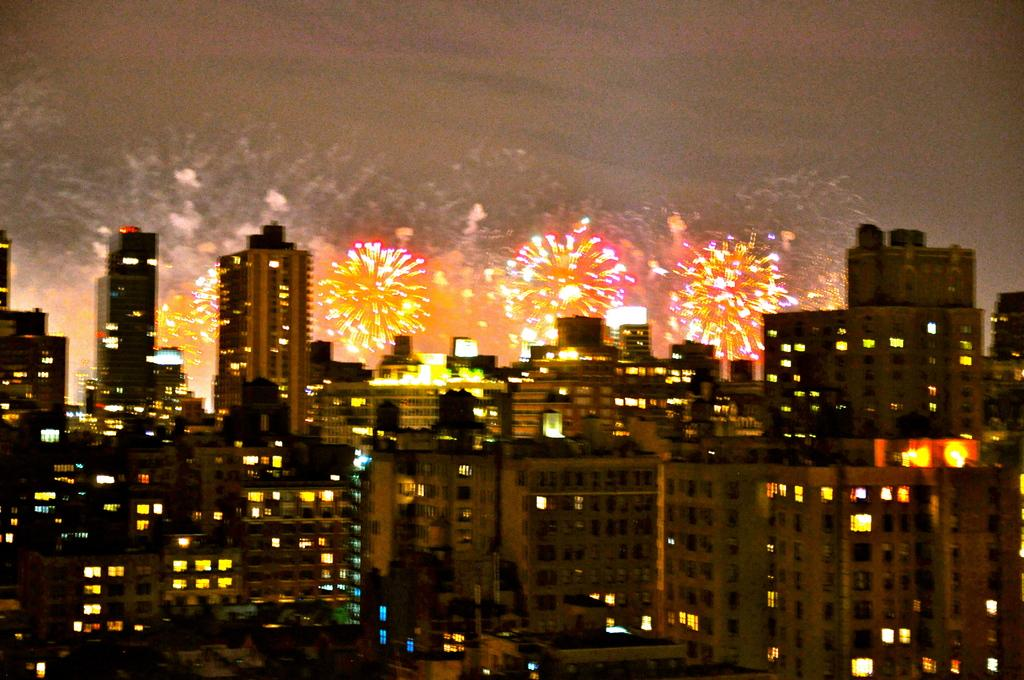What type of structures can be seen in the image? There are buildings in the image. What feature is common to many of the buildings? Windows are visible in the image. What can be seen illuminating the buildings? There are lights in the image. What is happening in the sky in the background of the image? There are sparks in the sky in the background of the image. What type of natural element is visible in the background of the image? Clouds are visible in the background of the image. What type of punishment is being carried out in the image? There is no indication of punishment in the image; it features buildings, windows, lights, sparks in the sky, and clouds. How many people are jumping in the image? There are no people jumping in the image; it focuses on buildings, windows, lights, sparks in the sky, and clouds. 